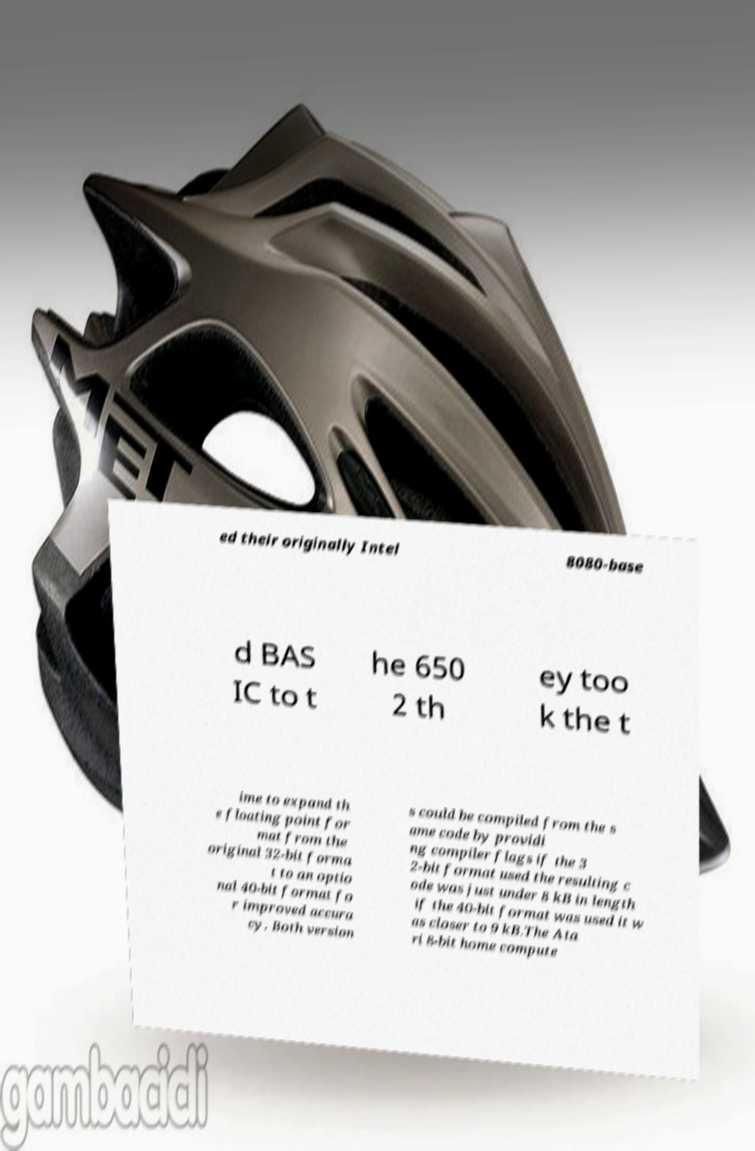What messages or text are displayed in this image? I need them in a readable, typed format. ed their originally Intel 8080-base d BAS IC to t he 650 2 th ey too k the t ime to expand th e floating point for mat from the original 32-bit forma t to an optio nal 40-bit format fo r improved accura cy. Both version s could be compiled from the s ame code by providi ng compiler flags if the 3 2-bit format used the resulting c ode was just under 8 kB in length if the 40-bit format was used it w as closer to 9 kB.The Ata ri 8-bit home compute 